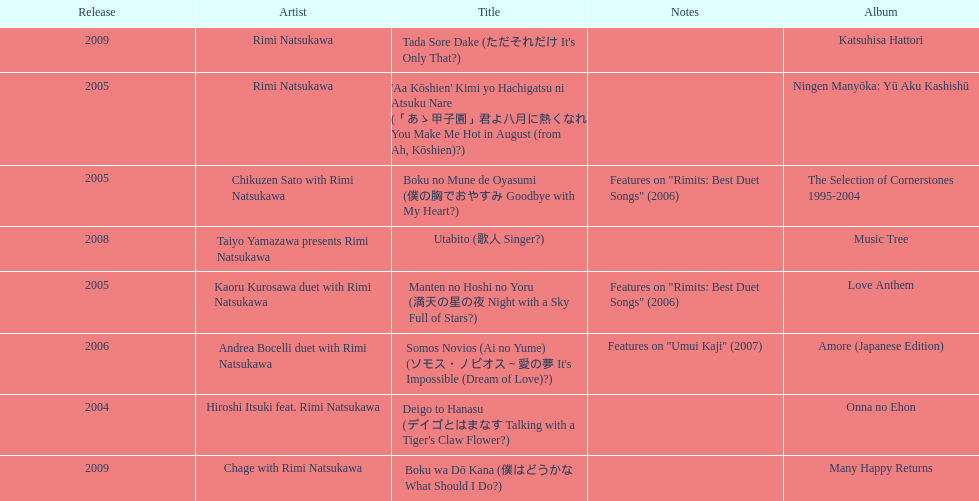What has been the last song this artist has made an other appearance on? Tada Sore Dake. 